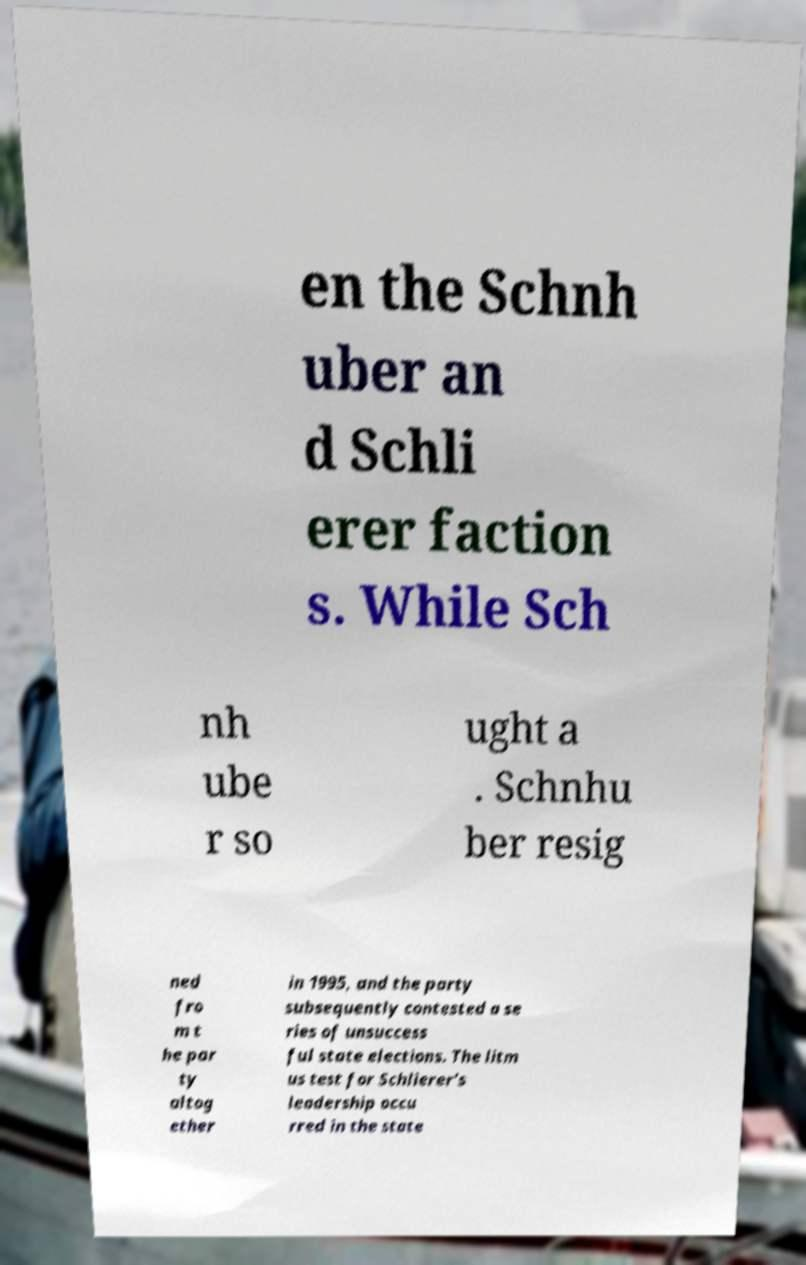What messages or text are displayed in this image? I need them in a readable, typed format. en the Schnh uber an d Schli erer faction s. While Sch nh ube r so ught a . Schnhu ber resig ned fro m t he par ty altog ether in 1995, and the party subsequently contested a se ries of unsuccess ful state elections. The litm us test for Schlierer's leadership occu rred in the state 